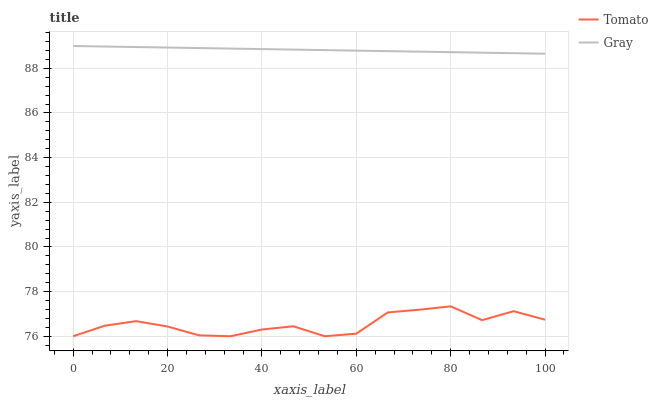Does Tomato have the minimum area under the curve?
Answer yes or no. Yes. Does Gray have the maximum area under the curve?
Answer yes or no. Yes. Does Gray have the minimum area under the curve?
Answer yes or no. No. Is Gray the smoothest?
Answer yes or no. Yes. Is Tomato the roughest?
Answer yes or no. Yes. Is Gray the roughest?
Answer yes or no. No. Does Tomato have the lowest value?
Answer yes or no. Yes. Does Gray have the lowest value?
Answer yes or no. No. Does Gray have the highest value?
Answer yes or no. Yes. Is Tomato less than Gray?
Answer yes or no. Yes. Is Gray greater than Tomato?
Answer yes or no. Yes. Does Tomato intersect Gray?
Answer yes or no. No. 